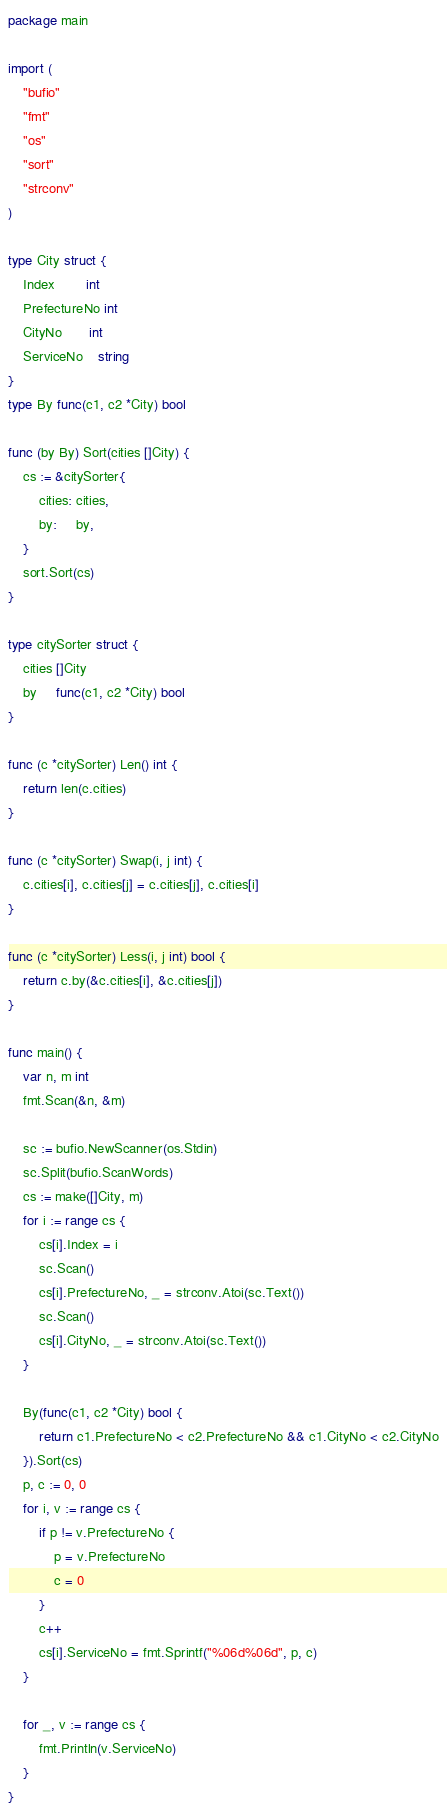Convert code to text. <code><loc_0><loc_0><loc_500><loc_500><_Go_>package main

import (
	"bufio"
	"fmt"
	"os"
	"sort"
	"strconv"
)

type City struct {
	Index        int
	PrefectureNo int
	CityNo       int
	ServiceNo    string
}
type By func(c1, c2 *City) bool

func (by By) Sort(cities []City) {
	cs := &citySorter{
		cities: cities,
		by:     by,
	}
	sort.Sort(cs)
}

type citySorter struct {
	cities []City
	by     func(c1, c2 *City) bool
}

func (c *citySorter) Len() int {
	return len(c.cities)
}

func (c *citySorter) Swap(i, j int) {
	c.cities[i], c.cities[j] = c.cities[j], c.cities[i]
}

func (c *citySorter) Less(i, j int) bool {
	return c.by(&c.cities[i], &c.cities[j])
}

func main() {
	var n, m int
	fmt.Scan(&n, &m)

	sc := bufio.NewScanner(os.Stdin)
	sc.Split(bufio.ScanWords)
	cs := make([]City, m)
	for i := range cs {
		cs[i].Index = i
		sc.Scan()
		cs[i].PrefectureNo, _ = strconv.Atoi(sc.Text())
		sc.Scan()
		cs[i].CityNo, _ = strconv.Atoi(sc.Text())
	}

	By(func(c1, c2 *City) bool {
		return c1.PrefectureNo < c2.PrefectureNo && c1.CityNo < c2.CityNo
	}).Sort(cs)
	p, c := 0, 0
	for i, v := range cs {
		if p != v.PrefectureNo {
			p = v.PrefectureNo
			c = 0
		}
		c++
		cs[i].ServiceNo = fmt.Sprintf("%06d%06d", p, c)
	}

	for _, v := range cs {
		fmt.Println(v.ServiceNo)
	}
}
</code> 